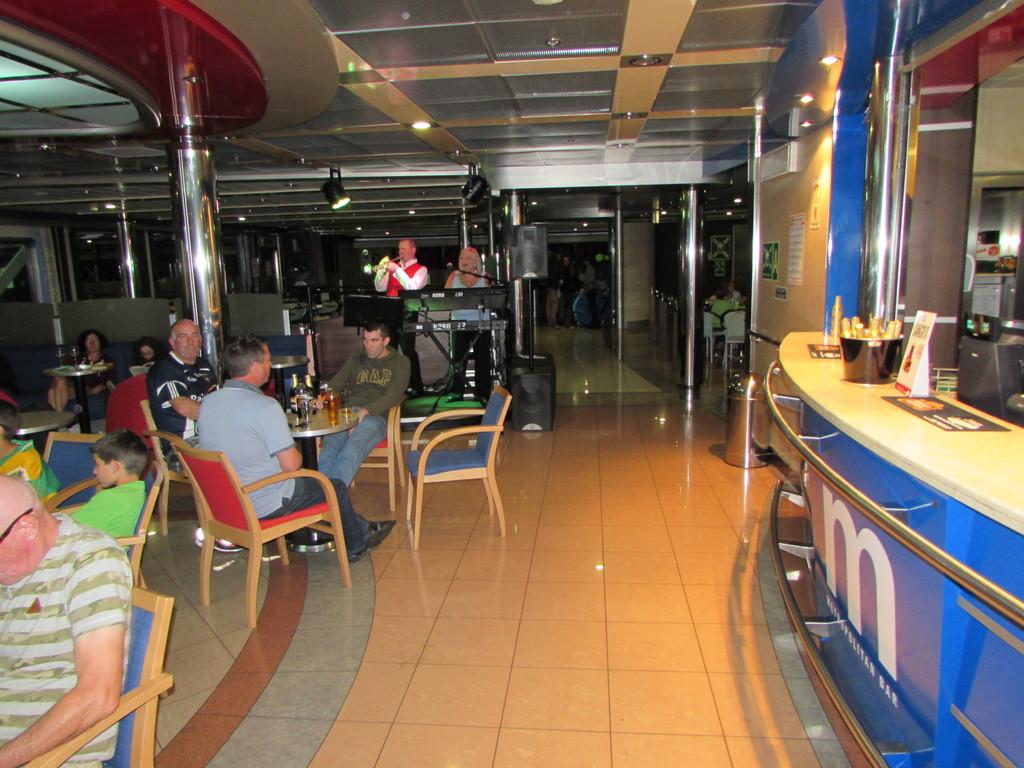What is happening in the left corner of the image? There is a group of people sitting in the left corner of the image. What are the two persons in the image doing? They are singing in front of a microphone. What can be seen in the right corner of the image? There is a counter in the right corner of the image. What type of quiver is visible on the side of the counter in the image? There is no quiver present in the image; it features a group of people sitting, two persons singing, and a counter. Where is the spot where the group of people are sitting in the image? The group of people are sitting in the left corner of the image. 